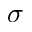<formula> <loc_0><loc_0><loc_500><loc_500>\sigma</formula> 